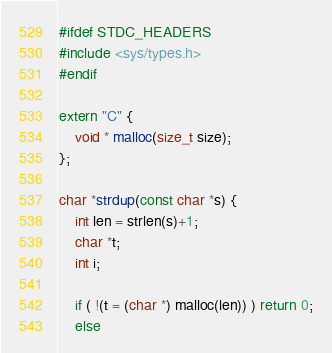Convert code to text. <code><loc_0><loc_0><loc_500><loc_500><_C++_>#ifdef STDC_HEADERS
#include <sys/types.h>
#endif

extern "C" {
    void * malloc(size_t size);
};

char *strdup(const char *s) {
    int len = strlen(s)+1;
    char *t;
    int i;

    if ( !(t = (char *) malloc(len)) ) return 0;
    else</code> 